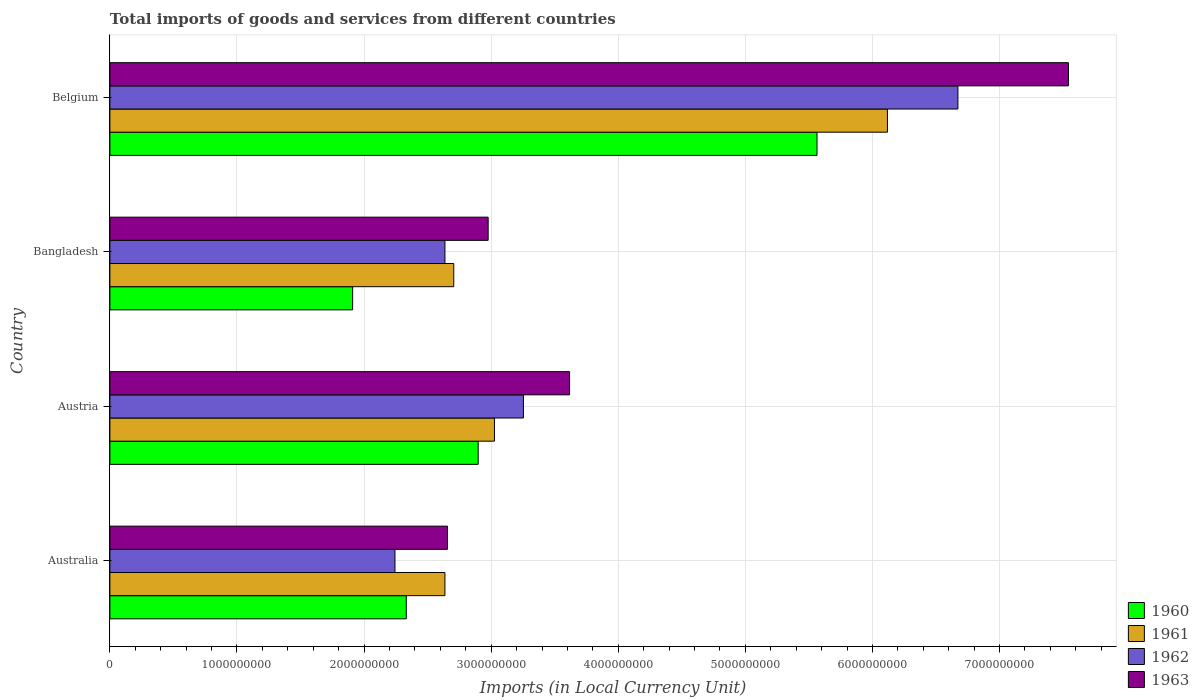How many different coloured bars are there?
Make the answer very short. 4. How many groups of bars are there?
Offer a terse response. 4. How many bars are there on the 2nd tick from the bottom?
Ensure brevity in your answer.  4. In how many cases, is the number of bars for a given country not equal to the number of legend labels?
Provide a succinct answer. 0. What is the Amount of goods and services imports in 1963 in Australia?
Your response must be concise. 2.66e+09. Across all countries, what is the maximum Amount of goods and services imports in 1962?
Keep it short and to the point. 6.67e+09. Across all countries, what is the minimum Amount of goods and services imports in 1961?
Give a very brief answer. 2.64e+09. In which country was the Amount of goods and services imports in 1963 maximum?
Make the answer very short. Belgium. What is the total Amount of goods and services imports in 1960 in the graph?
Keep it short and to the point. 1.27e+1. What is the difference between the Amount of goods and services imports in 1963 in Austria and that in Bangladesh?
Your answer should be very brief. 6.41e+08. What is the difference between the Amount of goods and services imports in 1963 in Bangladesh and the Amount of goods and services imports in 1960 in Australia?
Your answer should be compact. 6.44e+08. What is the average Amount of goods and services imports in 1961 per country?
Your answer should be compact. 3.62e+09. What is the difference between the Amount of goods and services imports in 1963 and Amount of goods and services imports in 1960 in Belgium?
Your answer should be compact. 1.98e+09. What is the ratio of the Amount of goods and services imports in 1963 in Bangladesh to that in Belgium?
Offer a terse response. 0.39. Is the difference between the Amount of goods and services imports in 1963 in Austria and Bangladesh greater than the difference between the Amount of goods and services imports in 1960 in Austria and Bangladesh?
Make the answer very short. No. What is the difference between the highest and the second highest Amount of goods and services imports in 1963?
Offer a very short reply. 3.93e+09. What is the difference between the highest and the lowest Amount of goods and services imports in 1961?
Give a very brief answer. 3.48e+09. Is it the case that in every country, the sum of the Amount of goods and services imports in 1961 and Amount of goods and services imports in 1962 is greater than the sum of Amount of goods and services imports in 1963 and Amount of goods and services imports in 1960?
Provide a succinct answer. Yes. What does the 1st bar from the top in Australia represents?
Your response must be concise. 1963. How many bars are there?
Make the answer very short. 16. Are all the bars in the graph horizontal?
Give a very brief answer. Yes. How many countries are there in the graph?
Give a very brief answer. 4. What is the difference between two consecutive major ticks on the X-axis?
Provide a short and direct response. 1.00e+09. Are the values on the major ticks of X-axis written in scientific E-notation?
Ensure brevity in your answer.  No. Does the graph contain grids?
Give a very brief answer. Yes. Where does the legend appear in the graph?
Make the answer very short. Bottom right. How are the legend labels stacked?
Give a very brief answer. Vertical. What is the title of the graph?
Your answer should be compact. Total imports of goods and services from different countries. Does "1990" appear as one of the legend labels in the graph?
Ensure brevity in your answer.  No. What is the label or title of the X-axis?
Give a very brief answer. Imports (in Local Currency Unit). What is the Imports (in Local Currency Unit) of 1960 in Australia?
Your response must be concise. 2.33e+09. What is the Imports (in Local Currency Unit) in 1961 in Australia?
Offer a terse response. 2.64e+09. What is the Imports (in Local Currency Unit) in 1962 in Australia?
Keep it short and to the point. 2.24e+09. What is the Imports (in Local Currency Unit) of 1963 in Australia?
Give a very brief answer. 2.66e+09. What is the Imports (in Local Currency Unit) of 1960 in Austria?
Give a very brief answer. 2.90e+09. What is the Imports (in Local Currency Unit) of 1961 in Austria?
Provide a short and direct response. 3.03e+09. What is the Imports (in Local Currency Unit) of 1962 in Austria?
Offer a very short reply. 3.25e+09. What is the Imports (in Local Currency Unit) of 1963 in Austria?
Your answer should be very brief. 3.62e+09. What is the Imports (in Local Currency Unit) in 1960 in Bangladesh?
Provide a short and direct response. 1.91e+09. What is the Imports (in Local Currency Unit) in 1961 in Bangladesh?
Your answer should be very brief. 2.71e+09. What is the Imports (in Local Currency Unit) of 1962 in Bangladesh?
Give a very brief answer. 2.64e+09. What is the Imports (in Local Currency Unit) of 1963 in Bangladesh?
Keep it short and to the point. 2.98e+09. What is the Imports (in Local Currency Unit) of 1960 in Belgium?
Your answer should be compact. 5.56e+09. What is the Imports (in Local Currency Unit) in 1961 in Belgium?
Your response must be concise. 6.12e+09. What is the Imports (in Local Currency Unit) in 1962 in Belgium?
Offer a very short reply. 6.67e+09. What is the Imports (in Local Currency Unit) in 1963 in Belgium?
Your answer should be compact. 7.54e+09. Across all countries, what is the maximum Imports (in Local Currency Unit) of 1960?
Keep it short and to the point. 5.56e+09. Across all countries, what is the maximum Imports (in Local Currency Unit) in 1961?
Ensure brevity in your answer.  6.12e+09. Across all countries, what is the maximum Imports (in Local Currency Unit) in 1962?
Offer a terse response. 6.67e+09. Across all countries, what is the maximum Imports (in Local Currency Unit) in 1963?
Your answer should be compact. 7.54e+09. Across all countries, what is the minimum Imports (in Local Currency Unit) of 1960?
Your response must be concise. 1.91e+09. Across all countries, what is the minimum Imports (in Local Currency Unit) of 1961?
Provide a succinct answer. 2.64e+09. Across all countries, what is the minimum Imports (in Local Currency Unit) of 1962?
Your answer should be compact. 2.24e+09. Across all countries, what is the minimum Imports (in Local Currency Unit) of 1963?
Offer a terse response. 2.66e+09. What is the total Imports (in Local Currency Unit) in 1960 in the graph?
Provide a succinct answer. 1.27e+1. What is the total Imports (in Local Currency Unit) of 1961 in the graph?
Your answer should be very brief. 1.45e+1. What is the total Imports (in Local Currency Unit) in 1962 in the graph?
Your answer should be very brief. 1.48e+1. What is the total Imports (in Local Currency Unit) in 1963 in the graph?
Provide a succinct answer. 1.68e+1. What is the difference between the Imports (in Local Currency Unit) in 1960 in Australia and that in Austria?
Your answer should be very brief. -5.66e+08. What is the difference between the Imports (in Local Currency Unit) of 1961 in Australia and that in Austria?
Your answer should be compact. -3.90e+08. What is the difference between the Imports (in Local Currency Unit) in 1962 in Australia and that in Austria?
Give a very brief answer. -1.01e+09. What is the difference between the Imports (in Local Currency Unit) in 1963 in Australia and that in Austria?
Your answer should be compact. -9.61e+08. What is the difference between the Imports (in Local Currency Unit) in 1960 in Australia and that in Bangladesh?
Offer a very short reply. 4.22e+08. What is the difference between the Imports (in Local Currency Unit) in 1961 in Australia and that in Bangladesh?
Offer a terse response. -6.96e+07. What is the difference between the Imports (in Local Currency Unit) in 1962 in Australia and that in Bangladesh?
Your response must be concise. -3.93e+08. What is the difference between the Imports (in Local Currency Unit) in 1963 in Australia and that in Bangladesh?
Your response must be concise. -3.20e+08. What is the difference between the Imports (in Local Currency Unit) in 1960 in Australia and that in Belgium?
Offer a terse response. -3.23e+09. What is the difference between the Imports (in Local Currency Unit) of 1961 in Australia and that in Belgium?
Give a very brief answer. -3.48e+09. What is the difference between the Imports (in Local Currency Unit) in 1962 in Australia and that in Belgium?
Give a very brief answer. -4.43e+09. What is the difference between the Imports (in Local Currency Unit) in 1963 in Australia and that in Belgium?
Your answer should be very brief. -4.89e+09. What is the difference between the Imports (in Local Currency Unit) in 1960 in Austria and that in Bangladesh?
Provide a succinct answer. 9.88e+08. What is the difference between the Imports (in Local Currency Unit) in 1961 in Austria and that in Bangladesh?
Give a very brief answer. 3.20e+08. What is the difference between the Imports (in Local Currency Unit) of 1962 in Austria and that in Bangladesh?
Make the answer very short. 6.18e+08. What is the difference between the Imports (in Local Currency Unit) of 1963 in Austria and that in Bangladesh?
Your answer should be very brief. 6.41e+08. What is the difference between the Imports (in Local Currency Unit) of 1960 in Austria and that in Belgium?
Your response must be concise. -2.67e+09. What is the difference between the Imports (in Local Currency Unit) in 1961 in Austria and that in Belgium?
Make the answer very short. -3.09e+09. What is the difference between the Imports (in Local Currency Unit) in 1962 in Austria and that in Belgium?
Your response must be concise. -3.42e+09. What is the difference between the Imports (in Local Currency Unit) of 1963 in Austria and that in Belgium?
Your response must be concise. -3.93e+09. What is the difference between the Imports (in Local Currency Unit) in 1960 in Bangladesh and that in Belgium?
Your answer should be very brief. -3.65e+09. What is the difference between the Imports (in Local Currency Unit) of 1961 in Bangladesh and that in Belgium?
Provide a short and direct response. -3.41e+09. What is the difference between the Imports (in Local Currency Unit) of 1962 in Bangladesh and that in Belgium?
Ensure brevity in your answer.  -4.04e+09. What is the difference between the Imports (in Local Currency Unit) of 1963 in Bangladesh and that in Belgium?
Provide a short and direct response. -4.57e+09. What is the difference between the Imports (in Local Currency Unit) in 1960 in Australia and the Imports (in Local Currency Unit) in 1961 in Austria?
Provide a succinct answer. -6.94e+08. What is the difference between the Imports (in Local Currency Unit) of 1960 in Australia and the Imports (in Local Currency Unit) of 1962 in Austria?
Offer a very short reply. -9.22e+08. What is the difference between the Imports (in Local Currency Unit) of 1960 in Australia and the Imports (in Local Currency Unit) of 1963 in Austria?
Your answer should be very brief. -1.28e+09. What is the difference between the Imports (in Local Currency Unit) of 1961 in Australia and the Imports (in Local Currency Unit) of 1962 in Austria?
Give a very brief answer. -6.18e+08. What is the difference between the Imports (in Local Currency Unit) of 1961 in Australia and the Imports (in Local Currency Unit) of 1963 in Austria?
Offer a terse response. -9.81e+08. What is the difference between the Imports (in Local Currency Unit) in 1962 in Australia and the Imports (in Local Currency Unit) in 1963 in Austria?
Ensure brevity in your answer.  -1.37e+09. What is the difference between the Imports (in Local Currency Unit) in 1960 in Australia and the Imports (in Local Currency Unit) in 1961 in Bangladesh?
Ensure brevity in your answer.  -3.74e+08. What is the difference between the Imports (in Local Currency Unit) of 1960 in Australia and the Imports (in Local Currency Unit) of 1962 in Bangladesh?
Offer a terse response. -3.04e+08. What is the difference between the Imports (in Local Currency Unit) in 1960 in Australia and the Imports (in Local Currency Unit) in 1963 in Bangladesh?
Ensure brevity in your answer.  -6.44e+08. What is the difference between the Imports (in Local Currency Unit) of 1961 in Australia and the Imports (in Local Currency Unit) of 1962 in Bangladesh?
Provide a short and direct response. -1.80e+05. What is the difference between the Imports (in Local Currency Unit) in 1961 in Australia and the Imports (in Local Currency Unit) in 1963 in Bangladesh?
Give a very brief answer. -3.40e+08. What is the difference between the Imports (in Local Currency Unit) in 1962 in Australia and the Imports (in Local Currency Unit) in 1963 in Bangladesh?
Ensure brevity in your answer.  -7.33e+08. What is the difference between the Imports (in Local Currency Unit) of 1960 in Australia and the Imports (in Local Currency Unit) of 1961 in Belgium?
Offer a very short reply. -3.79e+09. What is the difference between the Imports (in Local Currency Unit) in 1960 in Australia and the Imports (in Local Currency Unit) in 1962 in Belgium?
Give a very brief answer. -4.34e+09. What is the difference between the Imports (in Local Currency Unit) in 1960 in Australia and the Imports (in Local Currency Unit) in 1963 in Belgium?
Keep it short and to the point. -5.21e+09. What is the difference between the Imports (in Local Currency Unit) in 1961 in Australia and the Imports (in Local Currency Unit) in 1962 in Belgium?
Provide a short and direct response. -4.04e+09. What is the difference between the Imports (in Local Currency Unit) of 1961 in Australia and the Imports (in Local Currency Unit) of 1963 in Belgium?
Ensure brevity in your answer.  -4.91e+09. What is the difference between the Imports (in Local Currency Unit) of 1962 in Australia and the Imports (in Local Currency Unit) of 1963 in Belgium?
Keep it short and to the point. -5.30e+09. What is the difference between the Imports (in Local Currency Unit) of 1960 in Austria and the Imports (in Local Currency Unit) of 1961 in Bangladesh?
Offer a very short reply. 1.92e+08. What is the difference between the Imports (in Local Currency Unit) of 1960 in Austria and the Imports (in Local Currency Unit) of 1962 in Bangladesh?
Your answer should be compact. 2.62e+08. What is the difference between the Imports (in Local Currency Unit) of 1960 in Austria and the Imports (in Local Currency Unit) of 1963 in Bangladesh?
Your response must be concise. -7.85e+07. What is the difference between the Imports (in Local Currency Unit) of 1961 in Austria and the Imports (in Local Currency Unit) of 1962 in Bangladesh?
Make the answer very short. 3.90e+08. What is the difference between the Imports (in Local Currency Unit) in 1961 in Austria and the Imports (in Local Currency Unit) in 1963 in Bangladesh?
Offer a terse response. 4.96e+07. What is the difference between the Imports (in Local Currency Unit) in 1962 in Austria and the Imports (in Local Currency Unit) in 1963 in Bangladesh?
Your answer should be compact. 2.77e+08. What is the difference between the Imports (in Local Currency Unit) of 1960 in Austria and the Imports (in Local Currency Unit) of 1961 in Belgium?
Provide a succinct answer. -3.22e+09. What is the difference between the Imports (in Local Currency Unit) of 1960 in Austria and the Imports (in Local Currency Unit) of 1962 in Belgium?
Provide a short and direct response. -3.77e+09. What is the difference between the Imports (in Local Currency Unit) of 1960 in Austria and the Imports (in Local Currency Unit) of 1963 in Belgium?
Your response must be concise. -4.64e+09. What is the difference between the Imports (in Local Currency Unit) in 1961 in Austria and the Imports (in Local Currency Unit) in 1962 in Belgium?
Ensure brevity in your answer.  -3.65e+09. What is the difference between the Imports (in Local Currency Unit) in 1961 in Austria and the Imports (in Local Currency Unit) in 1963 in Belgium?
Your answer should be compact. -4.52e+09. What is the difference between the Imports (in Local Currency Unit) in 1962 in Austria and the Imports (in Local Currency Unit) in 1963 in Belgium?
Your response must be concise. -4.29e+09. What is the difference between the Imports (in Local Currency Unit) in 1960 in Bangladesh and the Imports (in Local Currency Unit) in 1961 in Belgium?
Ensure brevity in your answer.  -4.21e+09. What is the difference between the Imports (in Local Currency Unit) of 1960 in Bangladesh and the Imports (in Local Currency Unit) of 1962 in Belgium?
Your answer should be very brief. -4.76e+09. What is the difference between the Imports (in Local Currency Unit) in 1960 in Bangladesh and the Imports (in Local Currency Unit) in 1963 in Belgium?
Your response must be concise. -5.63e+09. What is the difference between the Imports (in Local Currency Unit) of 1961 in Bangladesh and the Imports (in Local Currency Unit) of 1962 in Belgium?
Your answer should be compact. -3.97e+09. What is the difference between the Imports (in Local Currency Unit) in 1961 in Bangladesh and the Imports (in Local Currency Unit) in 1963 in Belgium?
Offer a terse response. -4.84e+09. What is the difference between the Imports (in Local Currency Unit) of 1962 in Bangladesh and the Imports (in Local Currency Unit) of 1963 in Belgium?
Your answer should be very brief. -4.91e+09. What is the average Imports (in Local Currency Unit) in 1960 per country?
Your response must be concise. 3.18e+09. What is the average Imports (in Local Currency Unit) of 1961 per country?
Give a very brief answer. 3.62e+09. What is the average Imports (in Local Currency Unit) in 1962 per country?
Ensure brevity in your answer.  3.70e+09. What is the average Imports (in Local Currency Unit) of 1963 per country?
Give a very brief answer. 4.20e+09. What is the difference between the Imports (in Local Currency Unit) of 1960 and Imports (in Local Currency Unit) of 1961 in Australia?
Offer a very short reply. -3.04e+08. What is the difference between the Imports (in Local Currency Unit) in 1960 and Imports (in Local Currency Unit) in 1962 in Australia?
Offer a terse response. 8.90e+07. What is the difference between the Imports (in Local Currency Unit) in 1960 and Imports (in Local Currency Unit) in 1963 in Australia?
Your answer should be very brief. -3.24e+08. What is the difference between the Imports (in Local Currency Unit) of 1961 and Imports (in Local Currency Unit) of 1962 in Australia?
Offer a very short reply. 3.93e+08. What is the difference between the Imports (in Local Currency Unit) in 1961 and Imports (in Local Currency Unit) in 1963 in Australia?
Your answer should be compact. -2.00e+07. What is the difference between the Imports (in Local Currency Unit) of 1962 and Imports (in Local Currency Unit) of 1963 in Australia?
Your response must be concise. -4.13e+08. What is the difference between the Imports (in Local Currency Unit) in 1960 and Imports (in Local Currency Unit) in 1961 in Austria?
Your response must be concise. -1.28e+08. What is the difference between the Imports (in Local Currency Unit) in 1960 and Imports (in Local Currency Unit) in 1962 in Austria?
Your response must be concise. -3.56e+08. What is the difference between the Imports (in Local Currency Unit) of 1960 and Imports (in Local Currency Unit) of 1963 in Austria?
Offer a terse response. -7.19e+08. What is the difference between the Imports (in Local Currency Unit) in 1961 and Imports (in Local Currency Unit) in 1962 in Austria?
Give a very brief answer. -2.28e+08. What is the difference between the Imports (in Local Currency Unit) of 1961 and Imports (in Local Currency Unit) of 1963 in Austria?
Provide a short and direct response. -5.91e+08. What is the difference between the Imports (in Local Currency Unit) in 1962 and Imports (in Local Currency Unit) in 1963 in Austria?
Your answer should be compact. -3.63e+08. What is the difference between the Imports (in Local Currency Unit) in 1960 and Imports (in Local Currency Unit) in 1961 in Bangladesh?
Your answer should be compact. -7.96e+08. What is the difference between the Imports (in Local Currency Unit) in 1960 and Imports (in Local Currency Unit) in 1962 in Bangladesh?
Your answer should be compact. -7.26e+08. What is the difference between the Imports (in Local Currency Unit) of 1960 and Imports (in Local Currency Unit) of 1963 in Bangladesh?
Provide a succinct answer. -1.07e+09. What is the difference between the Imports (in Local Currency Unit) in 1961 and Imports (in Local Currency Unit) in 1962 in Bangladesh?
Offer a very short reply. 6.94e+07. What is the difference between the Imports (in Local Currency Unit) of 1961 and Imports (in Local Currency Unit) of 1963 in Bangladesh?
Offer a terse response. -2.71e+08. What is the difference between the Imports (in Local Currency Unit) of 1962 and Imports (in Local Currency Unit) of 1963 in Bangladesh?
Offer a very short reply. -3.40e+08. What is the difference between the Imports (in Local Currency Unit) in 1960 and Imports (in Local Currency Unit) in 1961 in Belgium?
Your answer should be compact. -5.54e+08. What is the difference between the Imports (in Local Currency Unit) of 1960 and Imports (in Local Currency Unit) of 1962 in Belgium?
Offer a terse response. -1.11e+09. What is the difference between the Imports (in Local Currency Unit) of 1960 and Imports (in Local Currency Unit) of 1963 in Belgium?
Your answer should be compact. -1.98e+09. What is the difference between the Imports (in Local Currency Unit) of 1961 and Imports (in Local Currency Unit) of 1962 in Belgium?
Provide a succinct answer. -5.54e+08. What is the difference between the Imports (in Local Currency Unit) in 1961 and Imports (in Local Currency Unit) in 1963 in Belgium?
Your answer should be compact. -1.42e+09. What is the difference between the Imports (in Local Currency Unit) in 1962 and Imports (in Local Currency Unit) in 1963 in Belgium?
Provide a succinct answer. -8.70e+08. What is the ratio of the Imports (in Local Currency Unit) of 1960 in Australia to that in Austria?
Make the answer very short. 0.8. What is the ratio of the Imports (in Local Currency Unit) in 1961 in Australia to that in Austria?
Offer a very short reply. 0.87. What is the ratio of the Imports (in Local Currency Unit) in 1962 in Australia to that in Austria?
Your answer should be compact. 0.69. What is the ratio of the Imports (in Local Currency Unit) of 1963 in Australia to that in Austria?
Offer a very short reply. 0.73. What is the ratio of the Imports (in Local Currency Unit) of 1960 in Australia to that in Bangladesh?
Your answer should be compact. 1.22. What is the ratio of the Imports (in Local Currency Unit) of 1961 in Australia to that in Bangladesh?
Your response must be concise. 0.97. What is the ratio of the Imports (in Local Currency Unit) of 1962 in Australia to that in Bangladesh?
Offer a very short reply. 0.85. What is the ratio of the Imports (in Local Currency Unit) of 1963 in Australia to that in Bangladesh?
Your answer should be very brief. 0.89. What is the ratio of the Imports (in Local Currency Unit) of 1960 in Australia to that in Belgium?
Your answer should be compact. 0.42. What is the ratio of the Imports (in Local Currency Unit) of 1961 in Australia to that in Belgium?
Keep it short and to the point. 0.43. What is the ratio of the Imports (in Local Currency Unit) of 1962 in Australia to that in Belgium?
Your answer should be compact. 0.34. What is the ratio of the Imports (in Local Currency Unit) of 1963 in Australia to that in Belgium?
Provide a succinct answer. 0.35. What is the ratio of the Imports (in Local Currency Unit) of 1960 in Austria to that in Bangladesh?
Give a very brief answer. 1.52. What is the ratio of the Imports (in Local Currency Unit) in 1961 in Austria to that in Bangladesh?
Provide a succinct answer. 1.12. What is the ratio of the Imports (in Local Currency Unit) in 1962 in Austria to that in Bangladesh?
Provide a succinct answer. 1.23. What is the ratio of the Imports (in Local Currency Unit) of 1963 in Austria to that in Bangladesh?
Provide a short and direct response. 1.22. What is the ratio of the Imports (in Local Currency Unit) of 1960 in Austria to that in Belgium?
Make the answer very short. 0.52. What is the ratio of the Imports (in Local Currency Unit) of 1961 in Austria to that in Belgium?
Provide a short and direct response. 0.49. What is the ratio of the Imports (in Local Currency Unit) in 1962 in Austria to that in Belgium?
Provide a succinct answer. 0.49. What is the ratio of the Imports (in Local Currency Unit) in 1963 in Austria to that in Belgium?
Your answer should be compact. 0.48. What is the ratio of the Imports (in Local Currency Unit) of 1960 in Bangladesh to that in Belgium?
Your answer should be compact. 0.34. What is the ratio of the Imports (in Local Currency Unit) of 1961 in Bangladesh to that in Belgium?
Make the answer very short. 0.44. What is the ratio of the Imports (in Local Currency Unit) in 1962 in Bangladesh to that in Belgium?
Your answer should be compact. 0.4. What is the ratio of the Imports (in Local Currency Unit) of 1963 in Bangladesh to that in Belgium?
Make the answer very short. 0.39. What is the difference between the highest and the second highest Imports (in Local Currency Unit) of 1960?
Ensure brevity in your answer.  2.67e+09. What is the difference between the highest and the second highest Imports (in Local Currency Unit) in 1961?
Make the answer very short. 3.09e+09. What is the difference between the highest and the second highest Imports (in Local Currency Unit) of 1962?
Make the answer very short. 3.42e+09. What is the difference between the highest and the second highest Imports (in Local Currency Unit) in 1963?
Offer a terse response. 3.93e+09. What is the difference between the highest and the lowest Imports (in Local Currency Unit) in 1960?
Offer a very short reply. 3.65e+09. What is the difference between the highest and the lowest Imports (in Local Currency Unit) of 1961?
Offer a terse response. 3.48e+09. What is the difference between the highest and the lowest Imports (in Local Currency Unit) of 1962?
Give a very brief answer. 4.43e+09. What is the difference between the highest and the lowest Imports (in Local Currency Unit) in 1963?
Keep it short and to the point. 4.89e+09. 